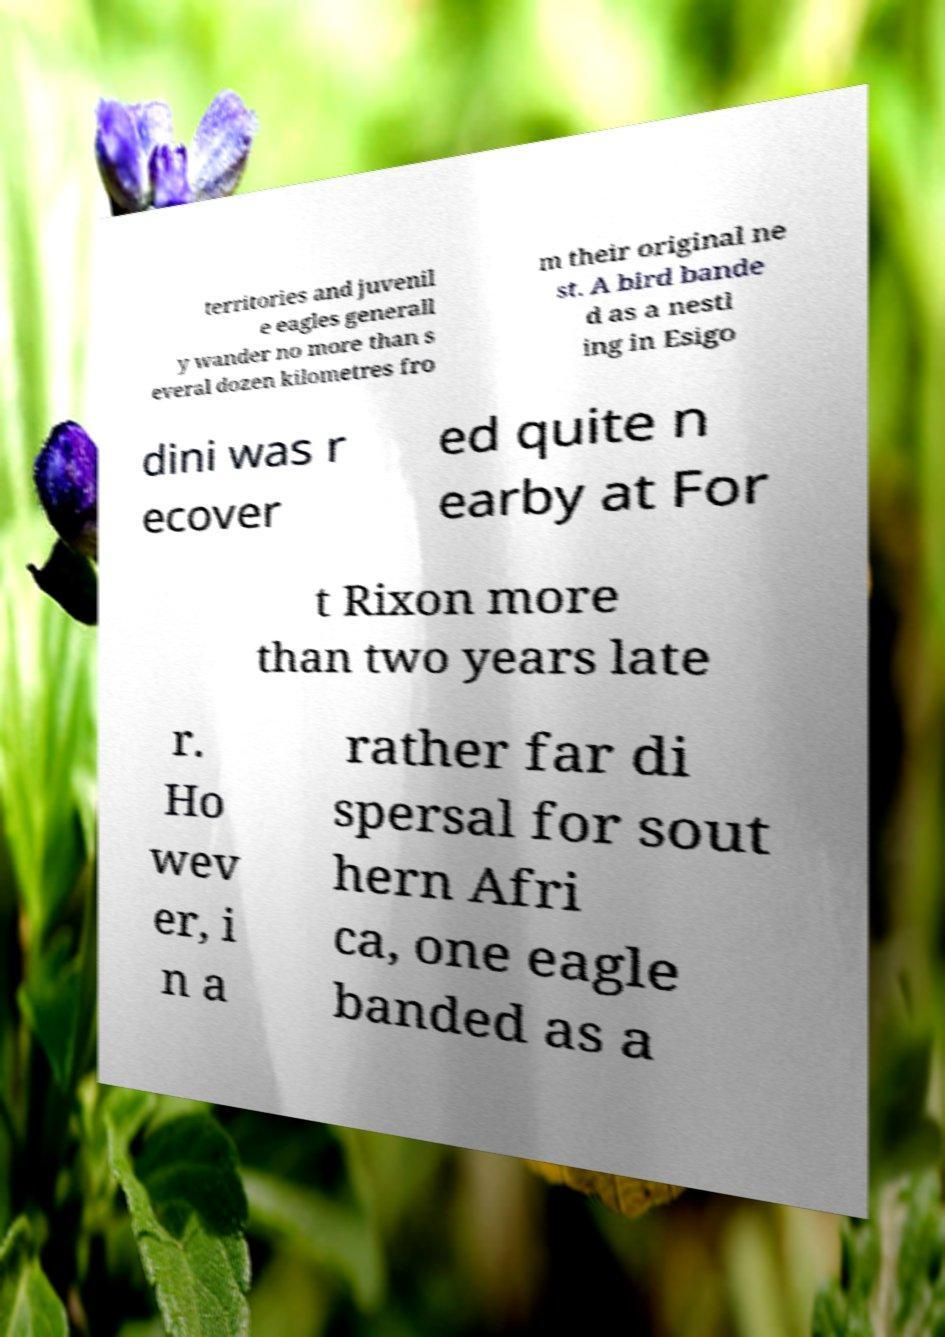What messages or text are displayed in this image? I need them in a readable, typed format. territories and juvenil e eagles generall y wander no more than s everal dozen kilometres fro m their original ne st. A bird bande d as a nestl ing in Esigo dini was r ecover ed quite n earby at For t Rixon more than two years late r. Ho wev er, i n a rather far di spersal for sout hern Afri ca, one eagle banded as a 